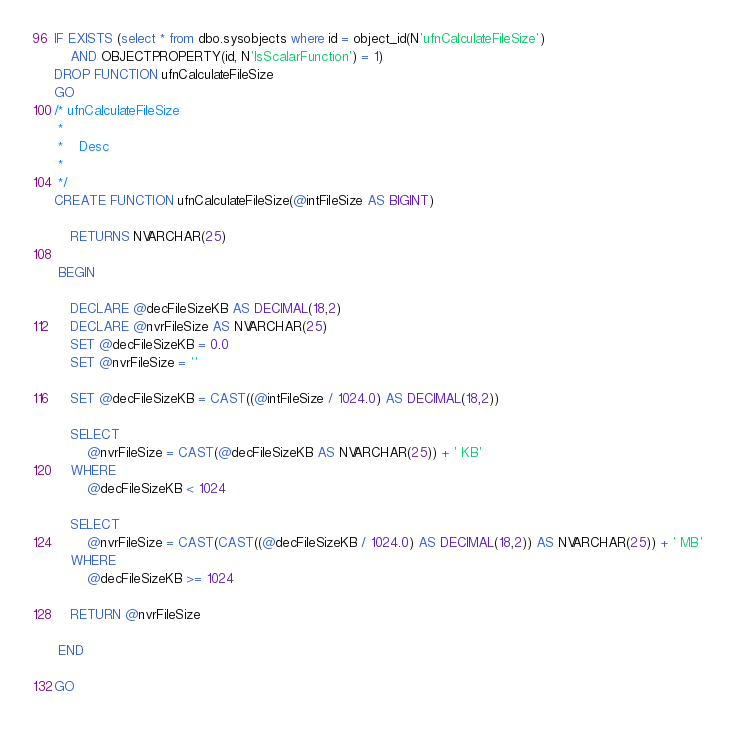<code> <loc_0><loc_0><loc_500><loc_500><_SQL_>IF EXISTS (select * from dbo.sysobjects where id = object_id(N'ufnCalculateFileSize') 
	AND OBJECTPROPERTY(id, N'IsScalarFunction') = 1)
DROP FUNCTION ufnCalculateFileSize
GO
/* ufnCalculateFileSize
 *
 *	Desc
 *
 */
CREATE FUNCTION ufnCalculateFileSize(@intFileSize AS BIGINT)

	RETURNS NVARCHAR(25)
	
 BEGIN

	DECLARE @decFileSizeKB AS DECIMAL(18,2)
	DECLARE @nvrFileSize AS NVARCHAR(25)
	SET @decFileSizeKB = 0.0
	SET @nvrFileSize = ''

	SET @decFileSizeKB = CAST((@intFileSize / 1024.0) AS DECIMAL(18,2))

	SELECT
		@nvrFileSize = CAST(@decFileSizeKB AS NVARCHAR(25)) + ' KB'
	WHERE 
		@decFileSizeKB < 1024

	SELECT
		@nvrFileSize = CAST(CAST((@decFileSizeKB / 1024.0) AS DECIMAL(18,2)) AS NVARCHAR(25)) + ' MB'
	WHERE 
		@decFileSizeKB >= 1024

	RETURN @nvrFileSize
	
 END

GO</code> 